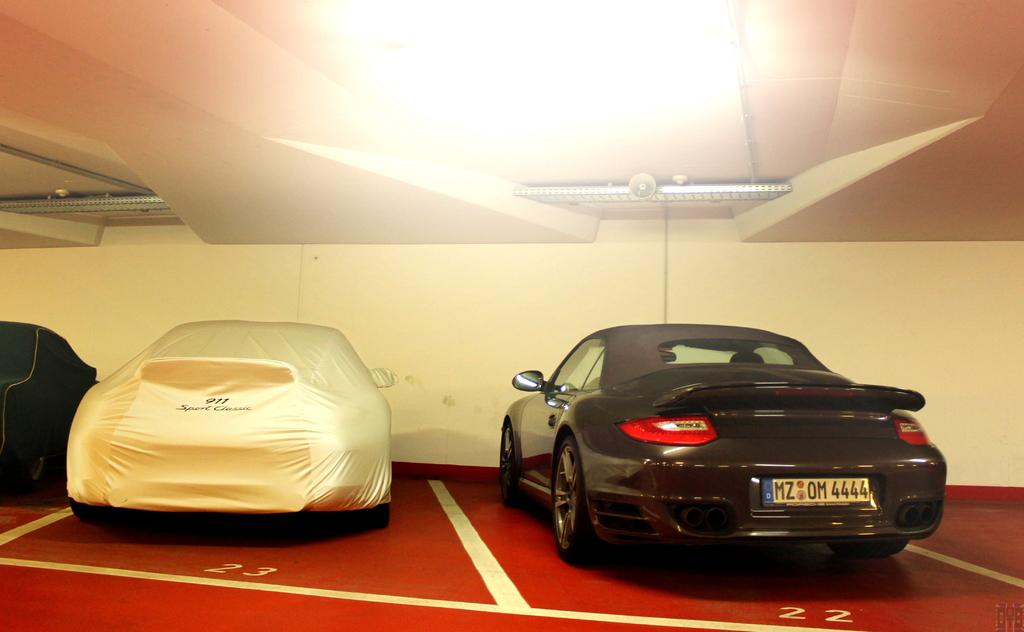What objects are on the floor in the image? There are cars on the floor in the image. Is there anything special about one of the cars? Yes, one car is covered with a cover. What can be seen extending from the floor to the ceiling in the image? There are metal rods extending to the ceiling in the image. What is attached to one of the metal rods? A speaker is attached to one of the metal rods. What day of the week is depicted in the image? The image does not depict a specific day of the week. Is there a sheet covering any of the cars in the image? No, there is no sheet covering any of the cars in the image; only one car is covered with a cover. 